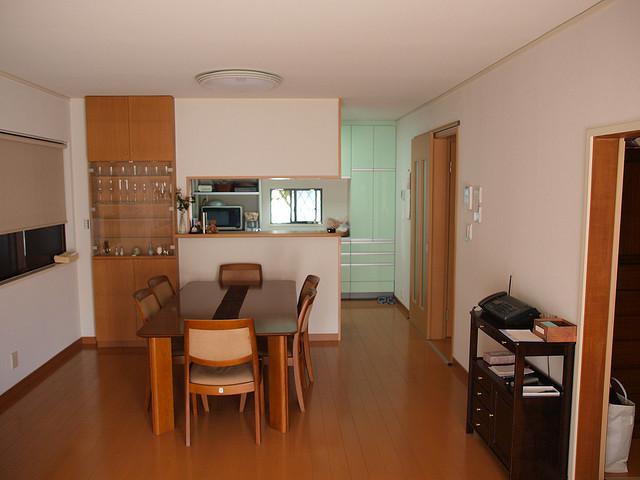Is there a fireplace?
Be succinct. No. What is the blue object in the corner of the room?
Write a very short answer. Shoes. Are all of the walls the same color?
Concise answer only. Yes. What will happen to the small room?
Short answer required. Dinner. How many tables are in the room?
Concise answer only. 2. Does "Messy Marvin" live here?
Write a very short answer. No. How many chairs are in the picture?
Concise answer only. 6. Is this room being remodeled?
Answer briefly. No. 